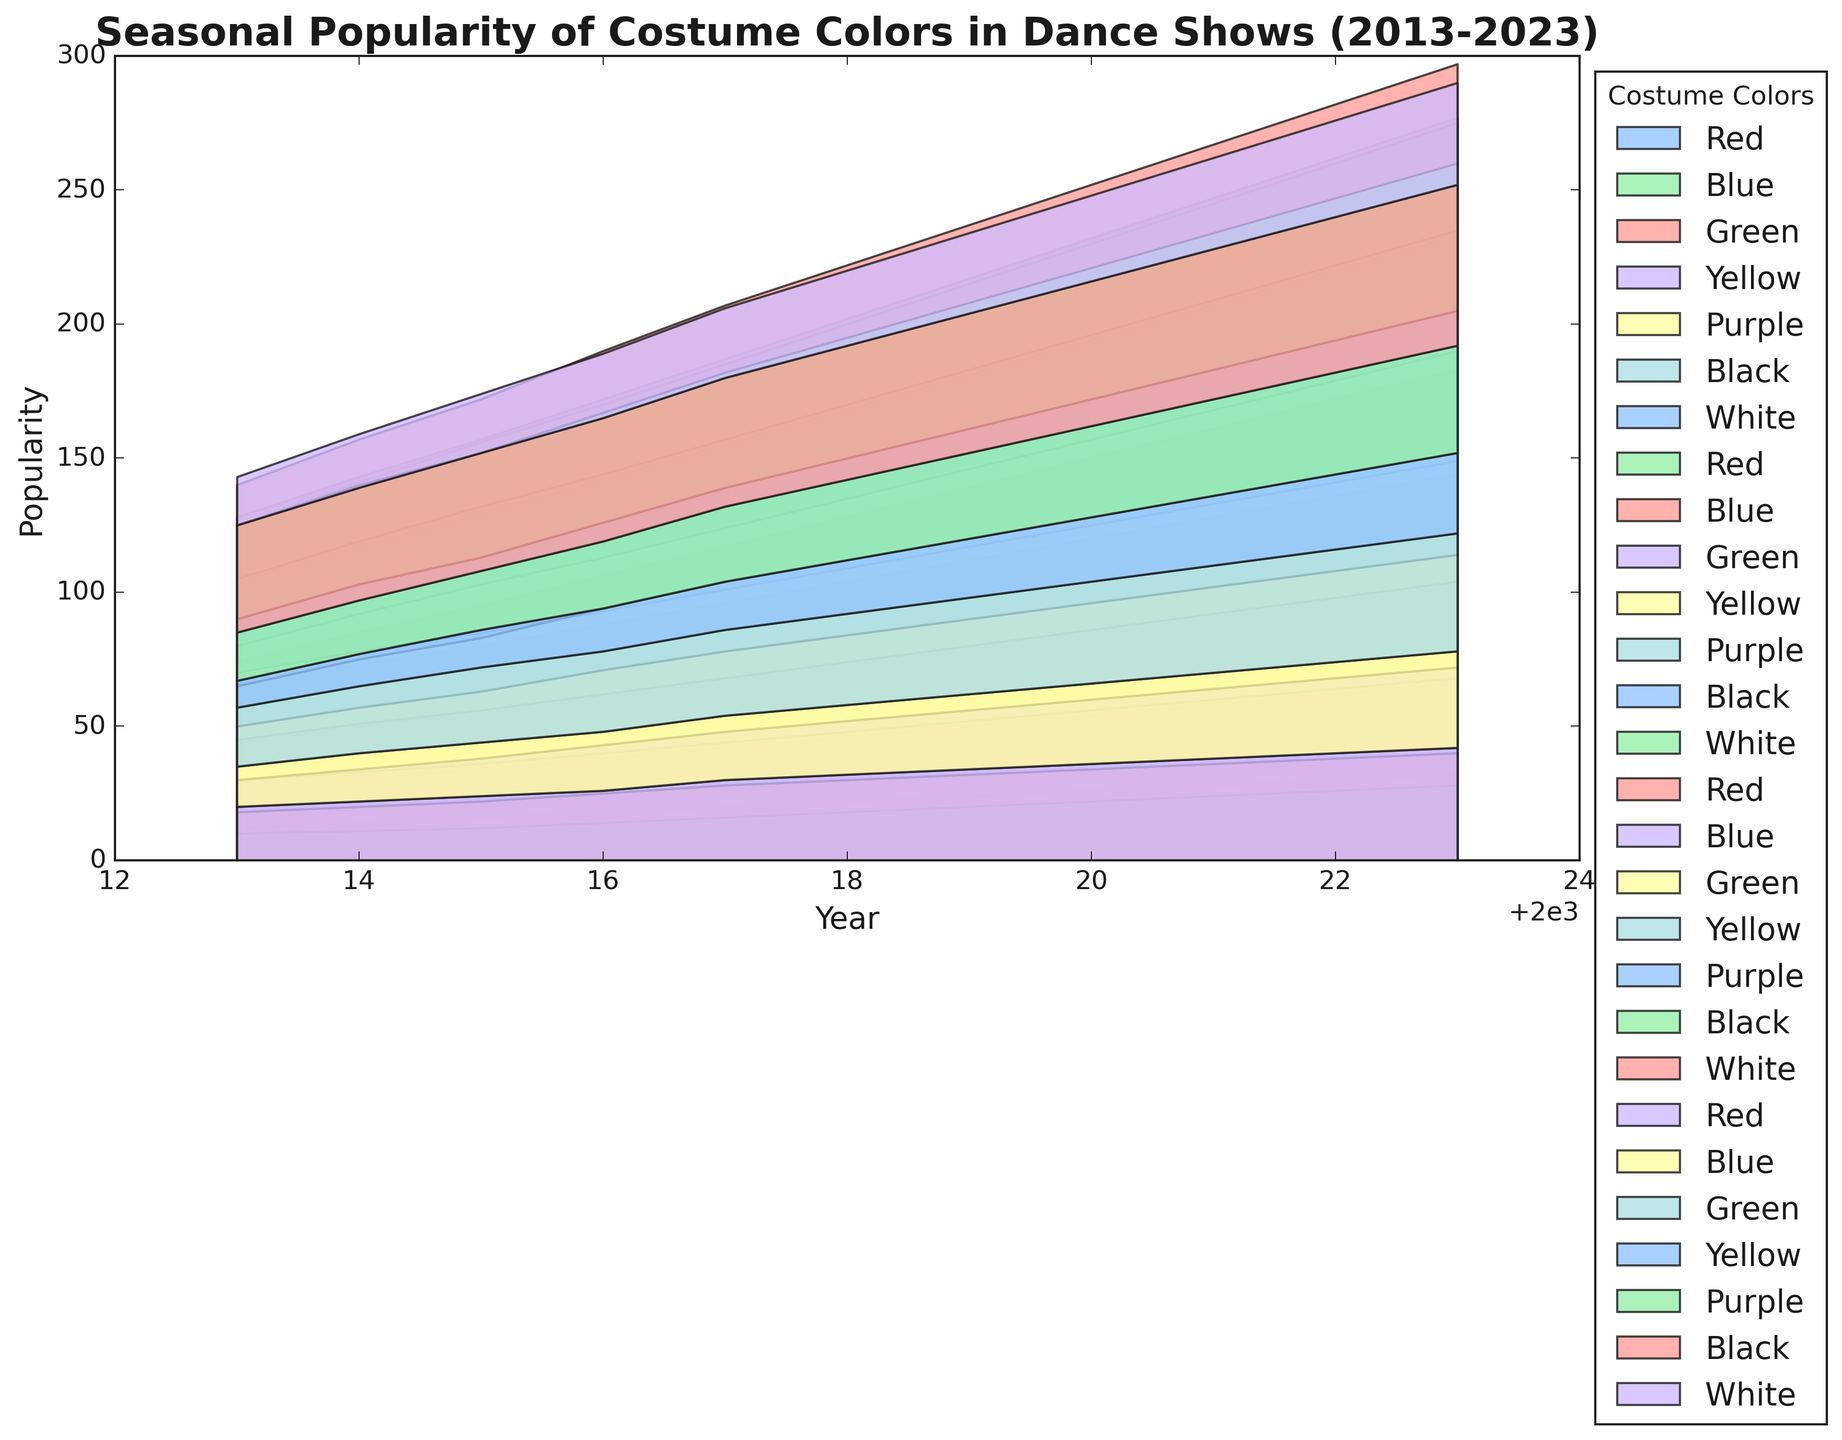How has the popularity of the color Black changed from 2013 to 2023 during Summer? To determine this, find the values for Black during Summer in the years 2013 and 2023 on the chart. In 2013, Black’s popularity in Summer was 25, while in 2023, it was 45. Comparing these values shows an increase.
Answer: It increased Which season consistently shows the highest popularity for Yellow over the years? To determine this, observe the area representing Yellow across all seasons from 2013 to 2023. Yellow consistently has higher values during the Summer season in most of the years when compared with other seasons.
Answer: Summer In which year and season did the color Purple reach its peak popularity? Look for the highest point in the area plot representing Purple. Observing the chart, Purple had peak popularity during Autumn 2023, where the value is the highest over the period.
Answer: Autumn 2023 Compare the popularity of Red in Spring 2017 and Spring 2019. Which year was it more popular? Identify and compare the heights of the Red area for Spring 2017 and Spring 2019. Red was at 20 in Spring 2017 and 24 in Spring 2019, indicating that it was more popular in 2019.
Answer: 2019 What is the average popularity of Green during Winter over the entire period? Identify Green's values during Winter for each year from 2013 to 2023: [22, 25, 28, 30, 32, 34, 36, 38, 40, 42, 44]. Sum these values: 22 + 25 + 28 + 30 + 32 + 34 + 36 + 38 + 40 + 42 + 44 = 371. Then divide by the number of Winter seasons: 371 / 11 = 33.73.
Answer: 33.73 Which color had the least variation in its popularity across all seasons from 2013 to 2023? Look for the area that has the most consistent width without drastic fluctuations. White shows the least variation in its popularity considering its relatively steady width across the entire period compared to other colors.
Answer: White During which season did Blue experience the least popularity in 2022? Examine the area representing Blue for each season in 2022 and identify the smallest section. In 2022, Blue had the least popularity during Autumn with a value of 30.
Answer: Autumn What was the total popularity of Yellow across all seasons in 2019? Find the values for Yellow during Spring, Summer, Autumn, and Winter of 2019: 32, 37, 30, and 22. Sum these values: 32 + 37 + 30 + 22 = 121.
Answer: 121 Which two colors combined have the highest popularity in Winter 2020? Identify the heights of the areas representing each color in Winter 2020: Red (36), Blue (30), Green (38), Yellow (24), Purple (34), Black (54), White (32). The two highest combined are Black and Green: 54 + 38 = 92.
Answer: Black and Green Between the years 2015 and 2020, which color showed the most growth in popularity in Spring? Compare the difference in Spring popularity for each color between 2015 and 2020. Most colors show growth, but Red saw an increase from 16 to 26, indicating significant growth.
Answer: Red 